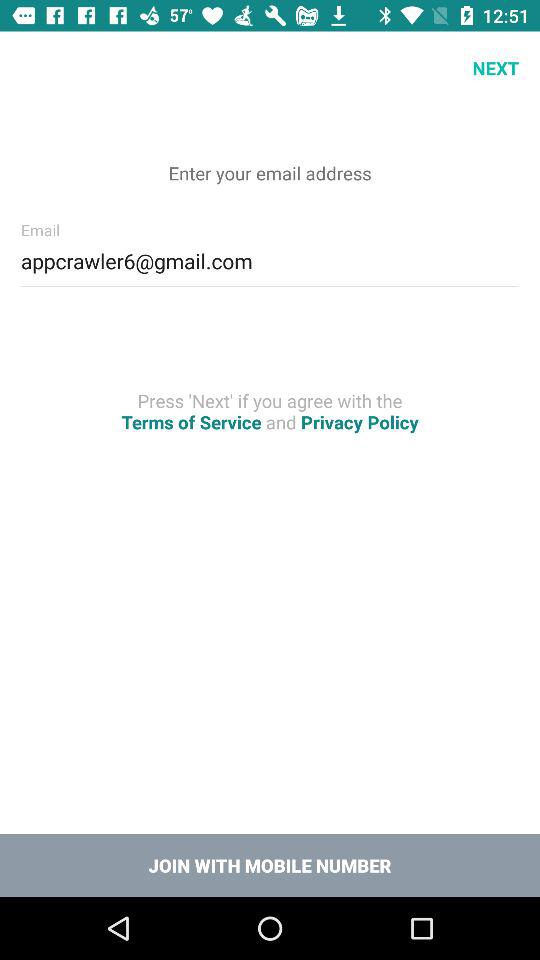Through what number can we join? You can join with a mobile number. 